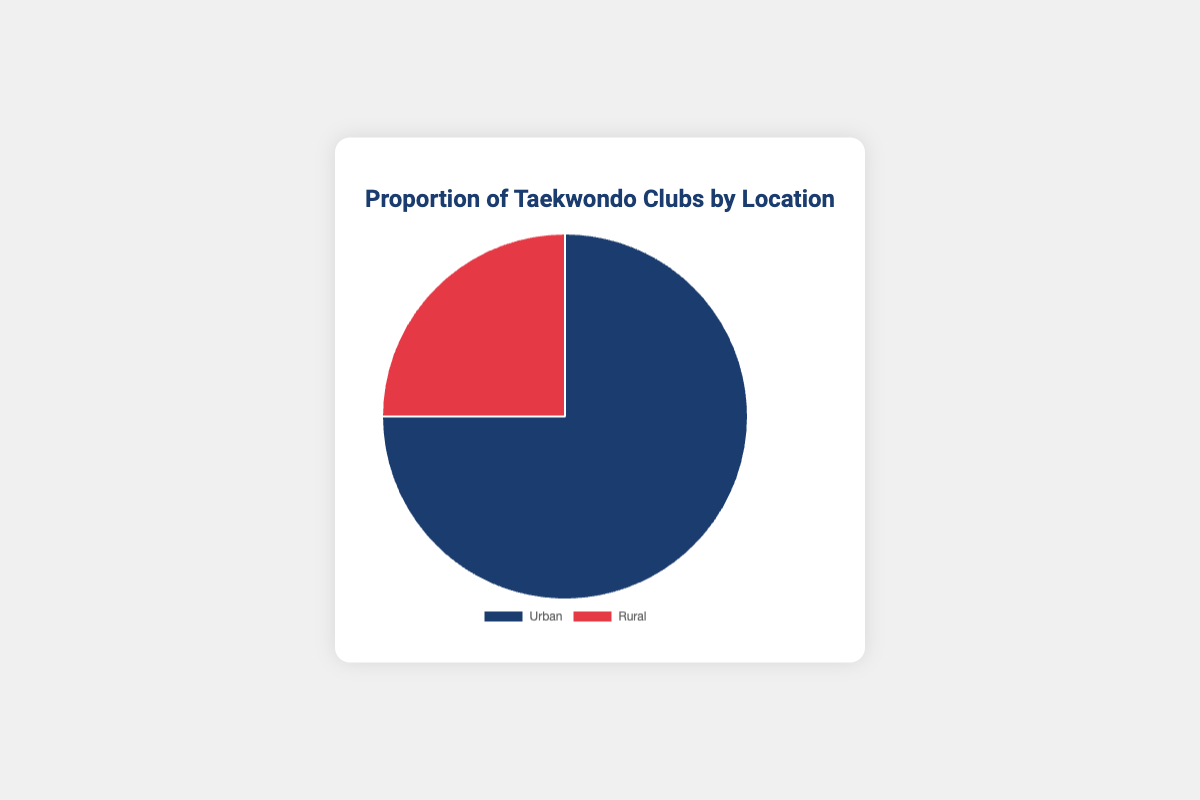What percentage of Taekwondo clubs are in urban areas? The pie chart shows that the segment labeled "Urban" occupies 75% of the entire chart.
Answer: 75% What percentage of Taekwondo clubs are in rural areas? The pie chart shows that the segment labeled "Rural" occupies 25% of the entire chart.
Answer: 25% Which type of location has more Taekwondo clubs, urban or rural? The pie chart indicates 75% for urban locations and 25% for rural locations. Therefore, urban locations have more clubs.
Answer: Urban How many times greater is the proportion of Taekwondo clubs in urban areas compared to rural areas? The proportion of urban clubs is 75%, and rural clubs is 25%. The ratio is 75/25 = 3.
Answer: 3 times What is the combined percentage of Taekwondo clubs in both urban and rural areas? The combined total must be 100% since these are the only two categories shown.
Answer: 100% What fraction of Taekwondo clubs are located in rural areas? The percentage of rural Taekwondo clubs is 25%, which can be expressed as the fraction 25/100 = 1/4.
Answer: 1/4 What is the difference in percentage between urban and rural Taekwondo clubs? Urban clubs are at 75%, and rural clubs are at 25%. The difference is 75% - 25% = 50%.
Answer: 50% Which segment occupies a larger visual space on the pie chart? The urban segment is visually larger since it represents 75% of the whole pie chart.
Answer: Urban If there are 100 Taekwondo clubs in total, how many would you expect to be located in rural areas? Since 25% of the clubs are rural, out of 100 clubs, 25% of 100 is 25.
Answer: 25 If the number of urban Taekwondo clubs is tripled, what percentage of the total would they now represent? If urban clubs are initially 75%, tripling this number would make the proportion 3 * 75% = 225%. However, since the total percentage must remain at 100%, this is a theoretical scenario to understand the ratio.
Answer: Theoretically 225%, but this exceeds 100% of a whole 